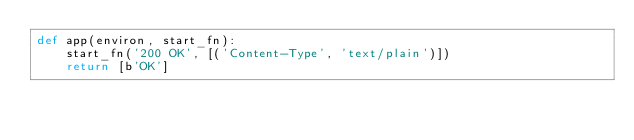Convert code to text. <code><loc_0><loc_0><loc_500><loc_500><_Python_>def app(environ, start_fn):
    start_fn('200 OK', [('Content-Type', 'text/plain')])
    return [b'OK']
</code> 